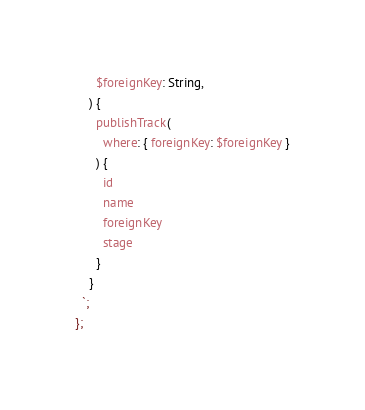Convert code to text. <code><loc_0><loc_0><loc_500><loc_500><_JavaScript_>      $foreignKey: String,  
    ) {
      publishTrack(
        where: { foreignKey: $foreignKey }
      ) {
        id
        name
        foreignKey
        stage
      }
    }  
  `;
};
</code> 